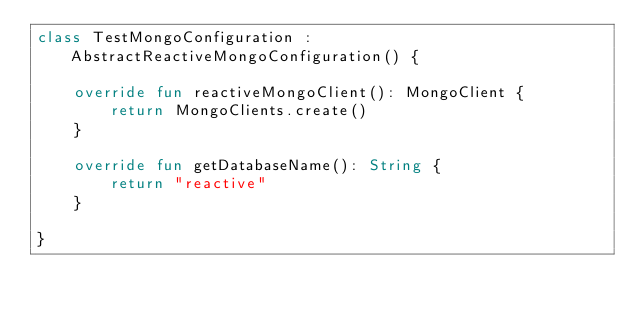Convert code to text. <code><loc_0><loc_0><loc_500><loc_500><_Kotlin_>class TestMongoConfiguration : AbstractReactiveMongoConfiguration() {

    override fun reactiveMongoClient(): MongoClient {
        return MongoClients.create()
    }

    override fun getDatabaseName(): String {
        return "reactive"
    }

}</code> 